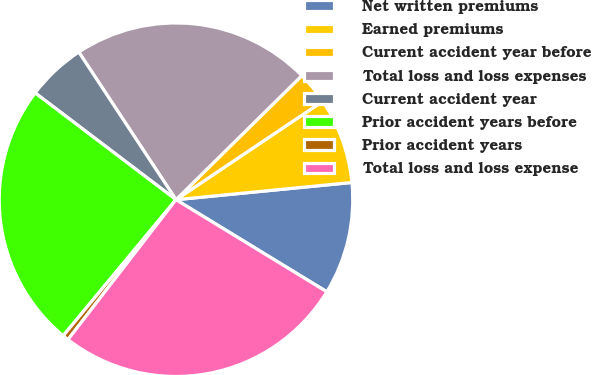Convert chart. <chart><loc_0><loc_0><loc_500><loc_500><pie_chart><fcel>Net written premiums<fcel>Earned premiums<fcel>Current accident year before<fcel>Total loss and loss expenses<fcel>Current accident year<fcel>Prior accident years before<fcel>Prior accident years<fcel>Total loss and loss expense<nl><fcel>10.28%<fcel>7.85%<fcel>2.98%<fcel>21.88%<fcel>5.41%<fcel>24.31%<fcel>0.55%<fcel>26.74%<nl></chart> 